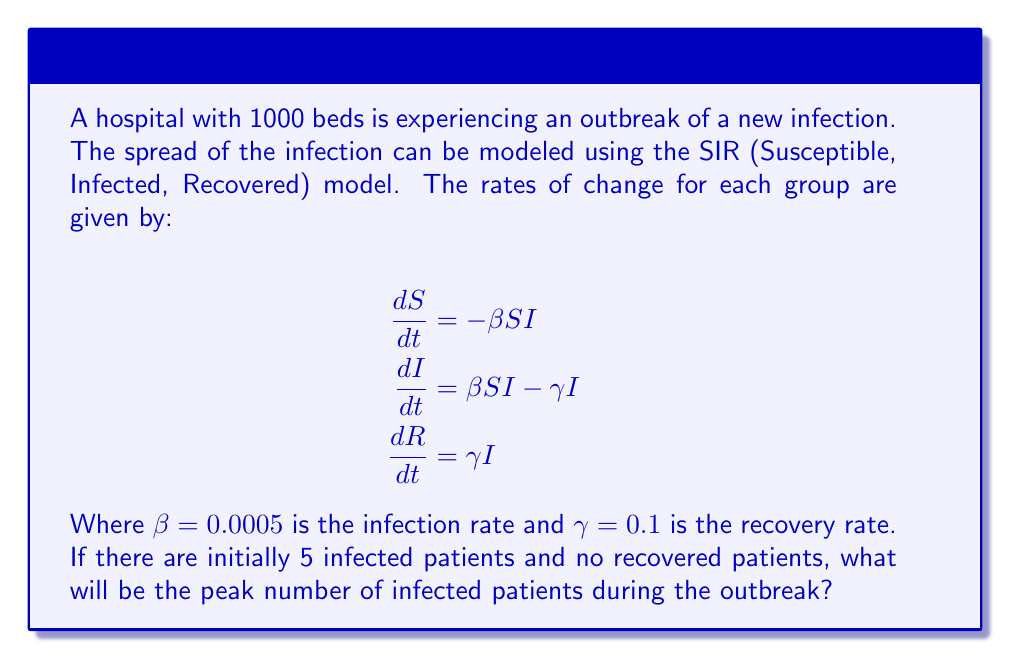Show me your answer to this math problem. To solve this problem, we'll follow these steps:

1) First, we need to understand the SIR model:
   S: Susceptible individuals
   I: Infected individuals
   R: Recovered individuals
   
   The total population N = S + I + R remains constant.

2) Initially, we have:
   S(0) = 995 (1000 - 5 initially infected)
   I(0) = 5
   R(0) = 0
   N = 1000

3) The peak of infection occurs when $\frac{dI}{dt} = 0$. At this point:

   $$\beta SI - \gamma I = 0$$
   $$\beta S = \gamma$$
   $$S = \frac{\gamma}{\beta} = \frac{0.1}{0.0005} = 200$$

4) We can use the conservation of total population to find I at this point:

   $$N = S + I + R$$
   $$1000 = 200 + I + R$$

5) We also know that the number of recovered individuals at any time is:

   $$R(t) = N - S(t) - I(t)$$

6) Substituting this into the equation from step 4:

   $$1000 = 200 + I + (1000 - 200 - I)$$
   $$1000 = 1000 - I$$
   $$I = 400$$

Therefore, the peak number of infected patients will be 400.
Answer: 400 patients 